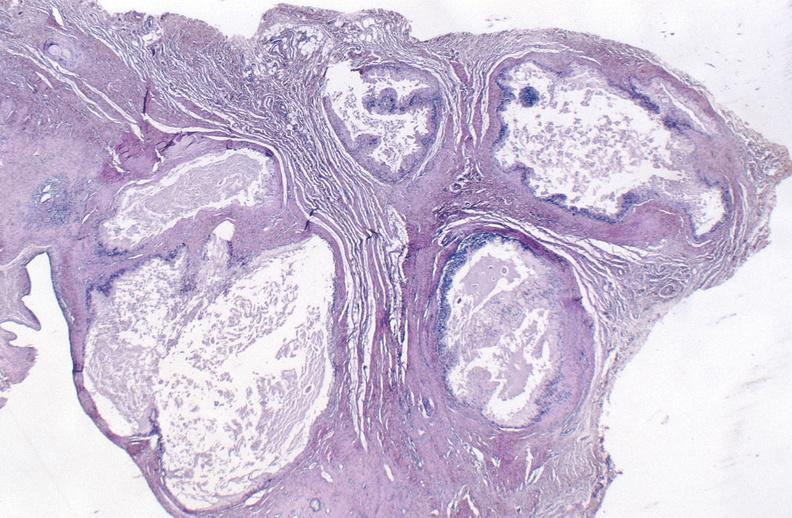s joints present?
Answer the question using a single word or phrase. Yes 